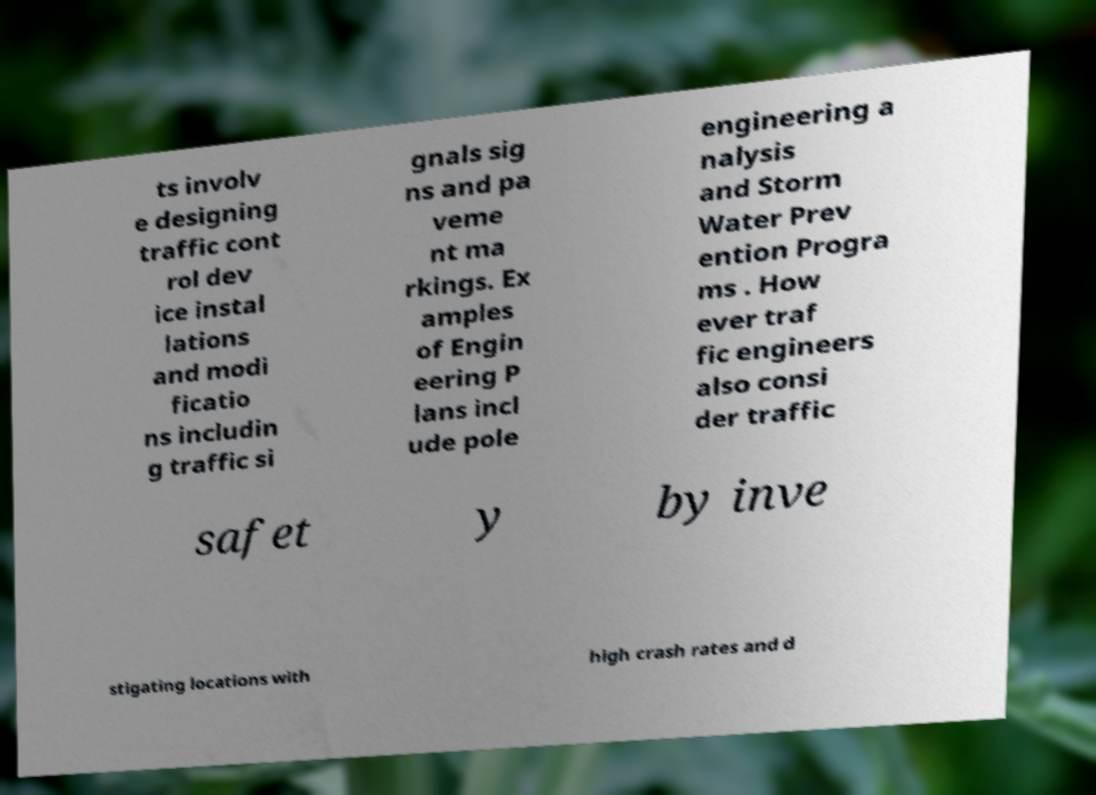Could you extract and type out the text from this image? ts involv e designing traffic cont rol dev ice instal lations and modi ficatio ns includin g traffic si gnals sig ns and pa veme nt ma rkings. Ex amples of Engin eering P lans incl ude pole engineering a nalysis and Storm Water Prev ention Progra ms . How ever traf fic engineers also consi der traffic safet y by inve stigating locations with high crash rates and d 